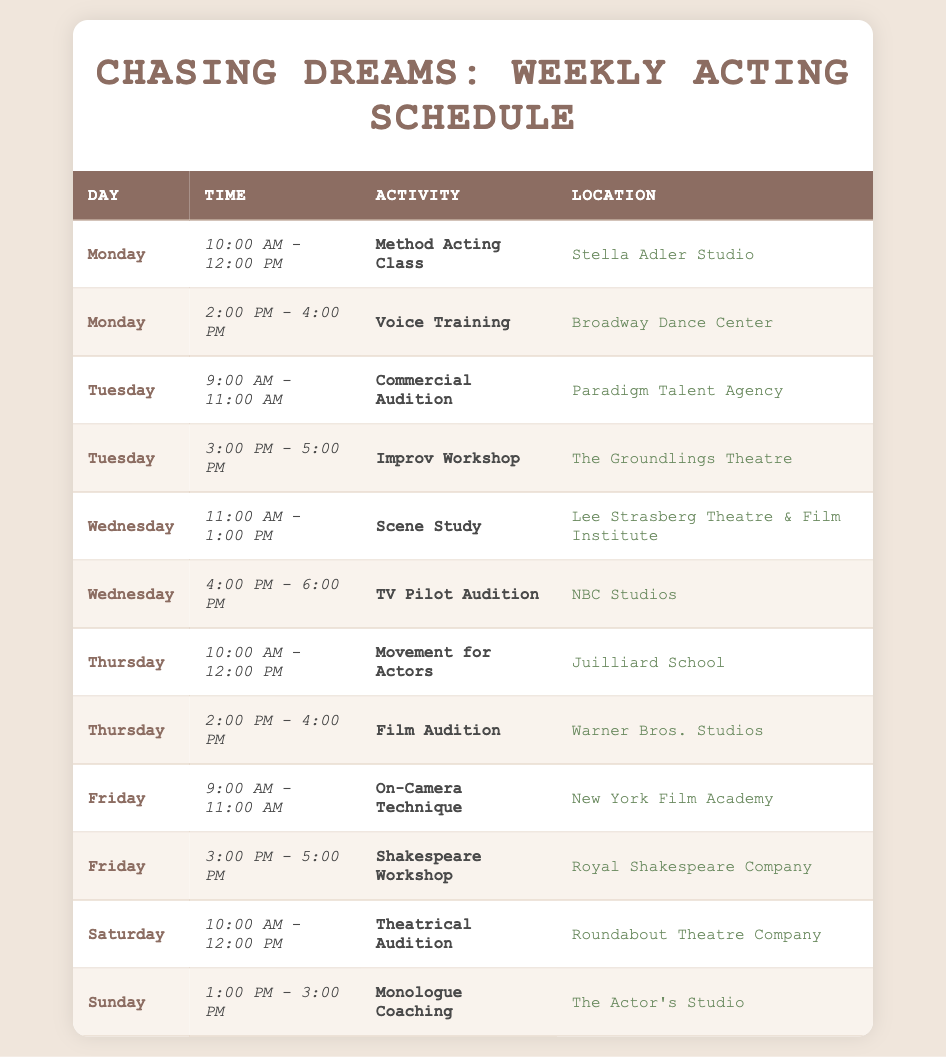What activity takes place on Wednesday from 11:00 AM to 1:00 PM? Referring to the table, on Wednesday during the specified time, the activity listed is "Scene Study".
Answer: Scene Study How many auditions are scheduled during the week? By counting the rows labeled as "Audition" in the Activity column, there are a total of 4 auditions: Commercial Audition, TV Pilot Audition, Film Audition, and Theatrical Audition.
Answer: 4 Is there a Voice Training session on Monday? The table shows that there is indeed a Voice Training session scheduled on Monday from 2:00 PM to 4:00 PM.
Answer: Yes What are the locations of all classes scheduled on Thursday? The entries for Thursday in the Location column show two classes: Movement for Actors at Juilliard School and Film Audition at Warner Bros. Studios.
Answer: Juilliard School and Warner Bros. Studios What is the difference in hours between the earliest and latest scheduled activity in the week? The earliest activity starts at 9:00 AM on Tuesday (Commercial Audition) and the latest activity ends at 6:00 PM on Wednesday (TV Pilot Audition). This gives a total time range of 9 hours (from 9:00 AM to 6:00 PM).
Answer: 9 hours Which day has the most activities scheduled? Counting the number of activities per day: Monday has 2, Tuesday has 2, Wednesday has 2, Thursday has 2, Friday has 2, Saturday has 1, and Sunday has 1. Each day from Monday to Thursday has the highest count of 2 activities.
Answer: Monday, Tuesday, Wednesday, and Thursday Are all the classes scheduled after 10:00 AM? Checking the schedule, there are sessions on Monday at 10:00 AM and a few others later, but there is also a session on Friday at 9:00 AM. Thus, not all classes are after 10:00 AM.
Answer: No What is the average time slot duration for EACH of the acting activities? Each activity is scheduled in 2-hour slots consistently throughout the week (from 10:00 AM to 12:00 PM, etc.). Hence, the average duration per activity is 2 hours, as observed.
Answer: 2 hours 